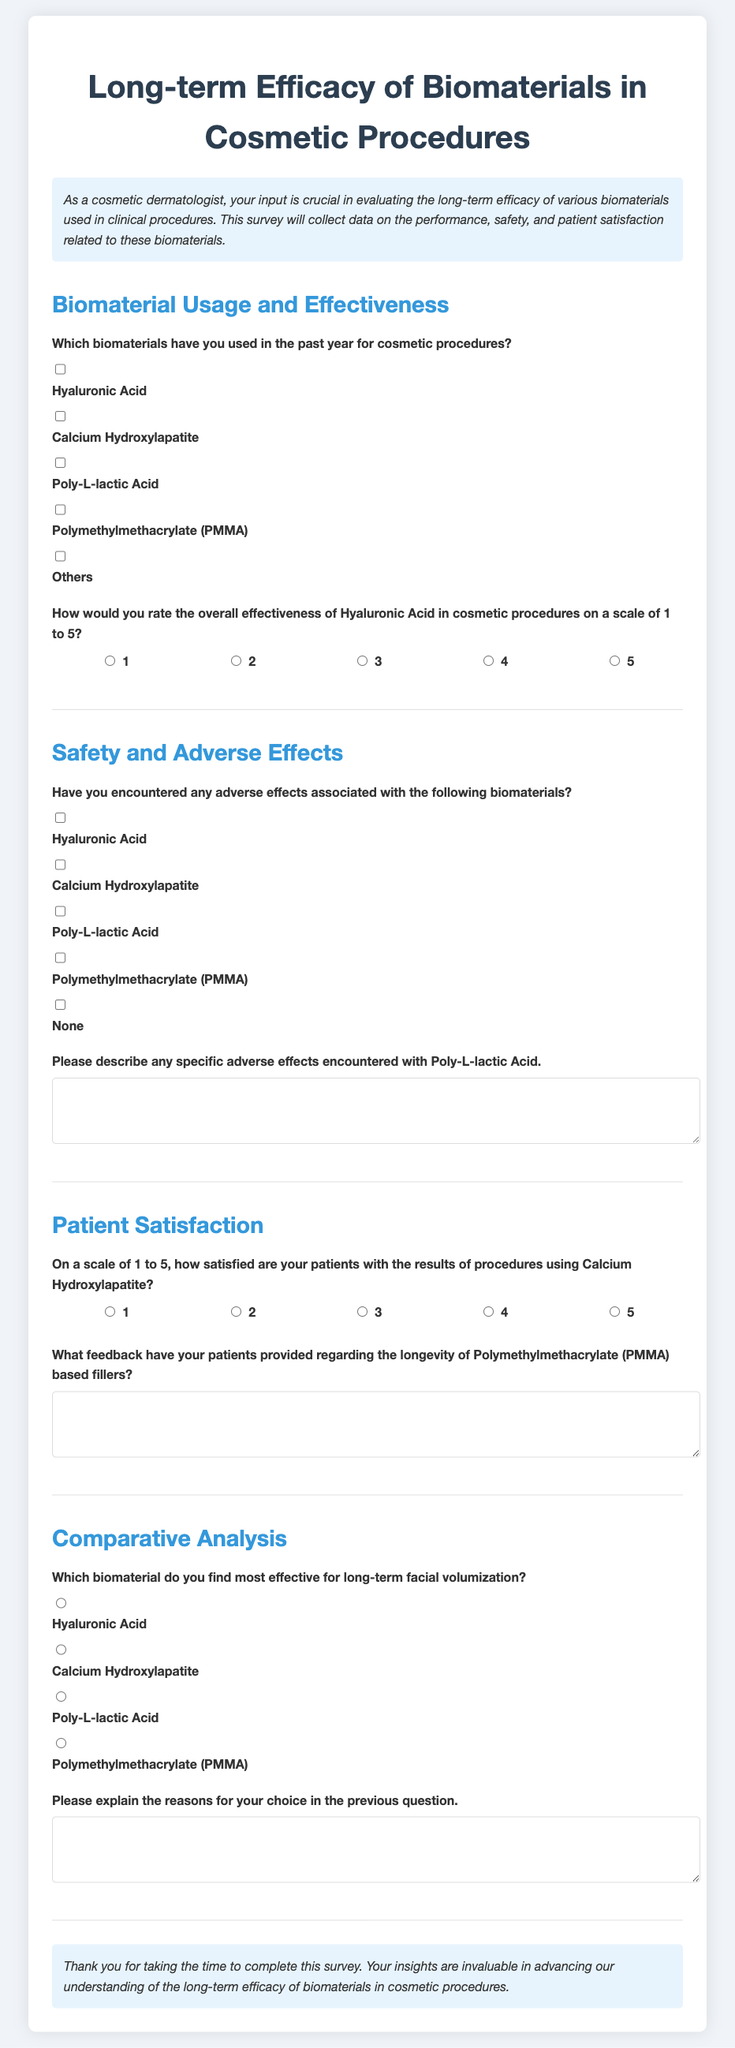What is the title of the survey? The title of the survey is displayed prominently at the top of the document.
Answer: Long-term Efficacy of Biomaterials in Cosmetic Procedures How many biomaterials are listed for selection? The document includes a list of biomaterials in the first section, which can be counted.
Answer: Five What scale is used to rate the effectiveness of Hyaluronic Acid? The document specifies the range for rating the effectiveness of a biomaterial.
Answer: 1 to 5 Which biomaterial is associated with the feedback question about longevity? The feedback question specifically mentions one of the biomaterials in relation to patient comments.
Answer: Polymethylmethacrylate (PMMA) What type of question asks for explanations regarding effectiveness? The document includes questions that prompt the respondent for detailed reasoning behind their selections.
Answer: Open-ended question On what scale are patient satisfaction ratings collected? The document indicates how patient satisfaction is to be measured in numerical terms.
Answer: 1 to 5 What style of form is used in the document? The survey is designed as an interactive form allowing for checkbox and radio button selections.
Answer: Survey form What does the introduction highlight as important for the survey? The introduction provides context and emphasizes the value of the respondents' input.
Answer: Evaluating long-term efficacy 